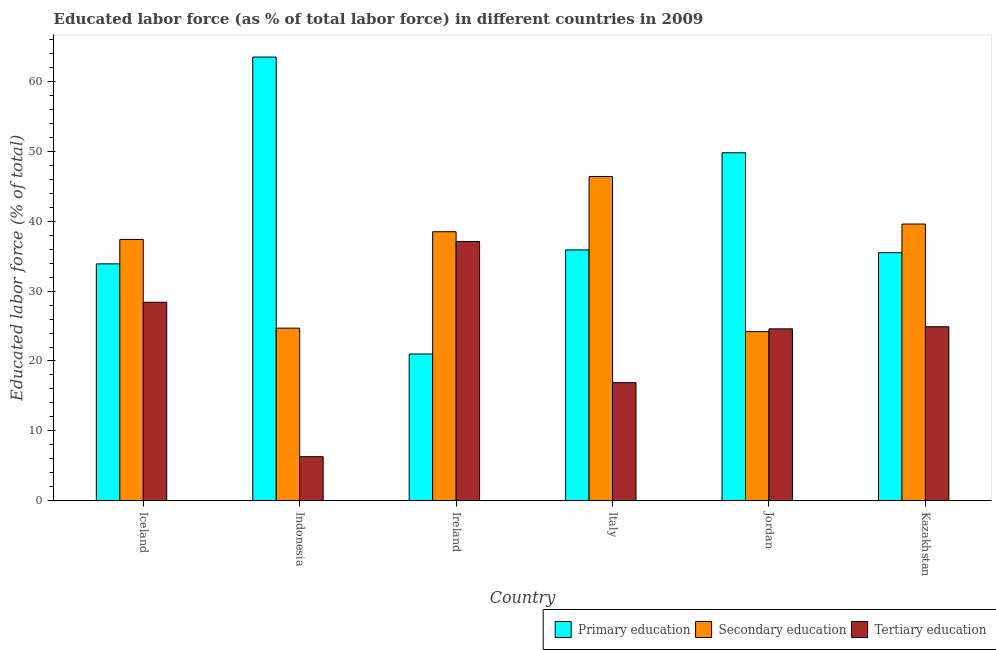How many different coloured bars are there?
Your answer should be very brief. 3. Are the number of bars per tick equal to the number of legend labels?
Provide a short and direct response. Yes. Are the number of bars on each tick of the X-axis equal?
Offer a terse response. Yes. How many bars are there on the 2nd tick from the right?
Your answer should be very brief. 3. What is the label of the 1st group of bars from the left?
Offer a very short reply. Iceland. What is the percentage of labor force who received primary education in Iceland?
Give a very brief answer. 33.9. Across all countries, what is the maximum percentage of labor force who received primary education?
Your answer should be very brief. 63.5. Across all countries, what is the minimum percentage of labor force who received primary education?
Offer a terse response. 21. In which country was the percentage of labor force who received tertiary education maximum?
Provide a short and direct response. Ireland. What is the total percentage of labor force who received primary education in the graph?
Keep it short and to the point. 239.6. What is the difference between the percentage of labor force who received tertiary education in Indonesia and that in Ireland?
Provide a succinct answer. -30.8. What is the difference between the percentage of labor force who received secondary education in Indonesia and the percentage of labor force who received tertiary education in Iceland?
Ensure brevity in your answer.  -3.7. What is the average percentage of labor force who received secondary education per country?
Give a very brief answer. 35.13. What is the difference between the percentage of labor force who received secondary education and percentage of labor force who received primary education in Italy?
Your answer should be very brief. 10.5. In how many countries, is the percentage of labor force who received primary education greater than 38 %?
Provide a succinct answer. 2. What is the ratio of the percentage of labor force who received secondary education in Iceland to that in Italy?
Your response must be concise. 0.81. What is the difference between the highest and the second highest percentage of labor force who received primary education?
Make the answer very short. 13.7. What is the difference between the highest and the lowest percentage of labor force who received primary education?
Your response must be concise. 42.5. In how many countries, is the percentage of labor force who received tertiary education greater than the average percentage of labor force who received tertiary education taken over all countries?
Provide a short and direct response. 4. Is the sum of the percentage of labor force who received primary education in Indonesia and Italy greater than the maximum percentage of labor force who received secondary education across all countries?
Ensure brevity in your answer.  Yes. What does the 3rd bar from the left in Jordan represents?
Provide a short and direct response. Tertiary education. What does the 2nd bar from the right in Jordan represents?
Ensure brevity in your answer.  Secondary education. How many bars are there?
Your answer should be very brief. 18. How many countries are there in the graph?
Keep it short and to the point. 6. What is the difference between two consecutive major ticks on the Y-axis?
Provide a succinct answer. 10. Does the graph contain any zero values?
Keep it short and to the point. No. How are the legend labels stacked?
Give a very brief answer. Horizontal. What is the title of the graph?
Give a very brief answer. Educated labor force (as % of total labor force) in different countries in 2009. What is the label or title of the X-axis?
Your answer should be very brief. Country. What is the label or title of the Y-axis?
Give a very brief answer. Educated labor force (% of total). What is the Educated labor force (% of total) in Primary education in Iceland?
Your response must be concise. 33.9. What is the Educated labor force (% of total) in Secondary education in Iceland?
Provide a succinct answer. 37.4. What is the Educated labor force (% of total) in Tertiary education in Iceland?
Keep it short and to the point. 28.4. What is the Educated labor force (% of total) of Primary education in Indonesia?
Offer a terse response. 63.5. What is the Educated labor force (% of total) in Secondary education in Indonesia?
Your response must be concise. 24.7. What is the Educated labor force (% of total) of Tertiary education in Indonesia?
Your response must be concise. 6.3. What is the Educated labor force (% of total) of Primary education in Ireland?
Offer a very short reply. 21. What is the Educated labor force (% of total) of Secondary education in Ireland?
Your response must be concise. 38.5. What is the Educated labor force (% of total) of Tertiary education in Ireland?
Keep it short and to the point. 37.1. What is the Educated labor force (% of total) of Primary education in Italy?
Your answer should be very brief. 35.9. What is the Educated labor force (% of total) of Secondary education in Italy?
Offer a very short reply. 46.4. What is the Educated labor force (% of total) in Tertiary education in Italy?
Keep it short and to the point. 16.9. What is the Educated labor force (% of total) of Primary education in Jordan?
Ensure brevity in your answer.  49.8. What is the Educated labor force (% of total) of Secondary education in Jordan?
Ensure brevity in your answer.  24.2. What is the Educated labor force (% of total) of Tertiary education in Jordan?
Give a very brief answer. 24.6. What is the Educated labor force (% of total) of Primary education in Kazakhstan?
Your answer should be compact. 35.5. What is the Educated labor force (% of total) in Secondary education in Kazakhstan?
Your response must be concise. 39.6. What is the Educated labor force (% of total) of Tertiary education in Kazakhstan?
Offer a very short reply. 24.9. Across all countries, what is the maximum Educated labor force (% of total) in Primary education?
Provide a succinct answer. 63.5. Across all countries, what is the maximum Educated labor force (% of total) in Secondary education?
Your answer should be compact. 46.4. Across all countries, what is the maximum Educated labor force (% of total) of Tertiary education?
Make the answer very short. 37.1. Across all countries, what is the minimum Educated labor force (% of total) in Primary education?
Your answer should be very brief. 21. Across all countries, what is the minimum Educated labor force (% of total) in Secondary education?
Provide a succinct answer. 24.2. Across all countries, what is the minimum Educated labor force (% of total) of Tertiary education?
Ensure brevity in your answer.  6.3. What is the total Educated labor force (% of total) in Primary education in the graph?
Your answer should be very brief. 239.6. What is the total Educated labor force (% of total) in Secondary education in the graph?
Your answer should be very brief. 210.8. What is the total Educated labor force (% of total) of Tertiary education in the graph?
Give a very brief answer. 138.2. What is the difference between the Educated labor force (% of total) of Primary education in Iceland and that in Indonesia?
Your answer should be very brief. -29.6. What is the difference between the Educated labor force (% of total) in Secondary education in Iceland and that in Indonesia?
Provide a succinct answer. 12.7. What is the difference between the Educated labor force (% of total) of Tertiary education in Iceland and that in Indonesia?
Your answer should be compact. 22.1. What is the difference between the Educated labor force (% of total) of Tertiary education in Iceland and that in Ireland?
Offer a very short reply. -8.7. What is the difference between the Educated labor force (% of total) of Secondary education in Iceland and that in Italy?
Ensure brevity in your answer.  -9. What is the difference between the Educated labor force (% of total) of Primary education in Iceland and that in Jordan?
Ensure brevity in your answer.  -15.9. What is the difference between the Educated labor force (% of total) of Tertiary education in Iceland and that in Jordan?
Your response must be concise. 3.8. What is the difference between the Educated labor force (% of total) of Secondary education in Iceland and that in Kazakhstan?
Provide a short and direct response. -2.2. What is the difference between the Educated labor force (% of total) of Primary education in Indonesia and that in Ireland?
Offer a terse response. 42.5. What is the difference between the Educated labor force (% of total) of Tertiary education in Indonesia and that in Ireland?
Your answer should be very brief. -30.8. What is the difference between the Educated labor force (% of total) in Primary education in Indonesia and that in Italy?
Make the answer very short. 27.6. What is the difference between the Educated labor force (% of total) in Secondary education in Indonesia and that in Italy?
Give a very brief answer. -21.7. What is the difference between the Educated labor force (% of total) of Tertiary education in Indonesia and that in Italy?
Your response must be concise. -10.6. What is the difference between the Educated labor force (% of total) in Primary education in Indonesia and that in Jordan?
Your answer should be compact. 13.7. What is the difference between the Educated labor force (% of total) in Tertiary education in Indonesia and that in Jordan?
Make the answer very short. -18.3. What is the difference between the Educated labor force (% of total) of Primary education in Indonesia and that in Kazakhstan?
Provide a short and direct response. 28. What is the difference between the Educated labor force (% of total) in Secondary education in Indonesia and that in Kazakhstan?
Provide a short and direct response. -14.9. What is the difference between the Educated labor force (% of total) of Tertiary education in Indonesia and that in Kazakhstan?
Keep it short and to the point. -18.6. What is the difference between the Educated labor force (% of total) in Primary education in Ireland and that in Italy?
Ensure brevity in your answer.  -14.9. What is the difference between the Educated labor force (% of total) in Secondary education in Ireland and that in Italy?
Provide a short and direct response. -7.9. What is the difference between the Educated labor force (% of total) in Tertiary education in Ireland and that in Italy?
Your answer should be very brief. 20.2. What is the difference between the Educated labor force (% of total) of Primary education in Ireland and that in Jordan?
Keep it short and to the point. -28.8. What is the difference between the Educated labor force (% of total) in Secondary education in Ireland and that in Kazakhstan?
Give a very brief answer. -1.1. What is the difference between the Educated labor force (% of total) of Tertiary education in Ireland and that in Kazakhstan?
Your answer should be compact. 12.2. What is the difference between the Educated labor force (% of total) in Primary education in Italy and that in Jordan?
Offer a terse response. -13.9. What is the difference between the Educated labor force (% of total) of Tertiary education in Italy and that in Jordan?
Make the answer very short. -7.7. What is the difference between the Educated labor force (% of total) of Primary education in Italy and that in Kazakhstan?
Provide a short and direct response. 0.4. What is the difference between the Educated labor force (% of total) of Tertiary education in Italy and that in Kazakhstan?
Your answer should be compact. -8. What is the difference between the Educated labor force (% of total) in Primary education in Jordan and that in Kazakhstan?
Make the answer very short. 14.3. What is the difference between the Educated labor force (% of total) in Secondary education in Jordan and that in Kazakhstan?
Offer a very short reply. -15.4. What is the difference between the Educated labor force (% of total) in Tertiary education in Jordan and that in Kazakhstan?
Offer a very short reply. -0.3. What is the difference between the Educated labor force (% of total) in Primary education in Iceland and the Educated labor force (% of total) in Tertiary education in Indonesia?
Make the answer very short. 27.6. What is the difference between the Educated labor force (% of total) of Secondary education in Iceland and the Educated labor force (% of total) of Tertiary education in Indonesia?
Keep it short and to the point. 31.1. What is the difference between the Educated labor force (% of total) of Secondary education in Iceland and the Educated labor force (% of total) of Tertiary education in Italy?
Offer a very short reply. 20.5. What is the difference between the Educated labor force (% of total) in Primary education in Iceland and the Educated labor force (% of total) in Secondary education in Jordan?
Your answer should be very brief. 9.7. What is the difference between the Educated labor force (% of total) of Secondary education in Iceland and the Educated labor force (% of total) of Tertiary education in Jordan?
Your answer should be compact. 12.8. What is the difference between the Educated labor force (% of total) of Secondary education in Iceland and the Educated labor force (% of total) of Tertiary education in Kazakhstan?
Your answer should be very brief. 12.5. What is the difference between the Educated labor force (% of total) of Primary education in Indonesia and the Educated labor force (% of total) of Secondary education in Ireland?
Offer a very short reply. 25. What is the difference between the Educated labor force (% of total) in Primary education in Indonesia and the Educated labor force (% of total) in Tertiary education in Ireland?
Provide a short and direct response. 26.4. What is the difference between the Educated labor force (% of total) in Secondary education in Indonesia and the Educated labor force (% of total) in Tertiary education in Ireland?
Provide a short and direct response. -12.4. What is the difference between the Educated labor force (% of total) in Primary education in Indonesia and the Educated labor force (% of total) in Tertiary education in Italy?
Your answer should be compact. 46.6. What is the difference between the Educated labor force (% of total) in Secondary education in Indonesia and the Educated labor force (% of total) in Tertiary education in Italy?
Your response must be concise. 7.8. What is the difference between the Educated labor force (% of total) in Primary education in Indonesia and the Educated labor force (% of total) in Secondary education in Jordan?
Ensure brevity in your answer.  39.3. What is the difference between the Educated labor force (% of total) of Primary education in Indonesia and the Educated labor force (% of total) of Tertiary education in Jordan?
Your answer should be very brief. 38.9. What is the difference between the Educated labor force (% of total) in Secondary education in Indonesia and the Educated labor force (% of total) in Tertiary education in Jordan?
Provide a succinct answer. 0.1. What is the difference between the Educated labor force (% of total) of Primary education in Indonesia and the Educated labor force (% of total) of Secondary education in Kazakhstan?
Ensure brevity in your answer.  23.9. What is the difference between the Educated labor force (% of total) in Primary education in Indonesia and the Educated labor force (% of total) in Tertiary education in Kazakhstan?
Your response must be concise. 38.6. What is the difference between the Educated labor force (% of total) in Secondary education in Indonesia and the Educated labor force (% of total) in Tertiary education in Kazakhstan?
Make the answer very short. -0.2. What is the difference between the Educated labor force (% of total) of Primary education in Ireland and the Educated labor force (% of total) of Secondary education in Italy?
Give a very brief answer. -25.4. What is the difference between the Educated labor force (% of total) in Primary education in Ireland and the Educated labor force (% of total) in Tertiary education in Italy?
Make the answer very short. 4.1. What is the difference between the Educated labor force (% of total) in Secondary education in Ireland and the Educated labor force (% of total) in Tertiary education in Italy?
Make the answer very short. 21.6. What is the difference between the Educated labor force (% of total) in Primary education in Ireland and the Educated labor force (% of total) in Secondary education in Kazakhstan?
Your answer should be very brief. -18.6. What is the difference between the Educated labor force (% of total) in Primary education in Italy and the Educated labor force (% of total) in Tertiary education in Jordan?
Provide a succinct answer. 11.3. What is the difference between the Educated labor force (% of total) of Secondary education in Italy and the Educated labor force (% of total) of Tertiary education in Jordan?
Offer a very short reply. 21.8. What is the difference between the Educated labor force (% of total) of Primary education in Italy and the Educated labor force (% of total) of Secondary education in Kazakhstan?
Your answer should be compact. -3.7. What is the difference between the Educated labor force (% of total) in Primary education in Jordan and the Educated labor force (% of total) in Tertiary education in Kazakhstan?
Give a very brief answer. 24.9. What is the difference between the Educated labor force (% of total) of Secondary education in Jordan and the Educated labor force (% of total) of Tertiary education in Kazakhstan?
Your response must be concise. -0.7. What is the average Educated labor force (% of total) in Primary education per country?
Provide a short and direct response. 39.93. What is the average Educated labor force (% of total) in Secondary education per country?
Give a very brief answer. 35.13. What is the average Educated labor force (% of total) in Tertiary education per country?
Your answer should be very brief. 23.03. What is the difference between the Educated labor force (% of total) of Primary education and Educated labor force (% of total) of Secondary education in Iceland?
Make the answer very short. -3.5. What is the difference between the Educated labor force (% of total) in Primary education and Educated labor force (% of total) in Tertiary education in Iceland?
Your answer should be compact. 5.5. What is the difference between the Educated labor force (% of total) in Secondary education and Educated labor force (% of total) in Tertiary education in Iceland?
Make the answer very short. 9. What is the difference between the Educated labor force (% of total) of Primary education and Educated labor force (% of total) of Secondary education in Indonesia?
Give a very brief answer. 38.8. What is the difference between the Educated labor force (% of total) of Primary education and Educated labor force (% of total) of Tertiary education in Indonesia?
Your answer should be compact. 57.2. What is the difference between the Educated labor force (% of total) of Primary education and Educated labor force (% of total) of Secondary education in Ireland?
Your answer should be very brief. -17.5. What is the difference between the Educated labor force (% of total) of Primary education and Educated labor force (% of total) of Tertiary education in Ireland?
Make the answer very short. -16.1. What is the difference between the Educated labor force (% of total) of Secondary education and Educated labor force (% of total) of Tertiary education in Ireland?
Offer a terse response. 1.4. What is the difference between the Educated labor force (% of total) in Secondary education and Educated labor force (% of total) in Tertiary education in Italy?
Offer a terse response. 29.5. What is the difference between the Educated labor force (% of total) of Primary education and Educated labor force (% of total) of Secondary education in Jordan?
Offer a very short reply. 25.6. What is the difference between the Educated labor force (% of total) of Primary education and Educated labor force (% of total) of Tertiary education in Jordan?
Provide a short and direct response. 25.2. What is the difference between the Educated labor force (% of total) of Primary education and Educated labor force (% of total) of Tertiary education in Kazakhstan?
Provide a succinct answer. 10.6. What is the ratio of the Educated labor force (% of total) in Primary education in Iceland to that in Indonesia?
Your answer should be very brief. 0.53. What is the ratio of the Educated labor force (% of total) in Secondary education in Iceland to that in Indonesia?
Offer a very short reply. 1.51. What is the ratio of the Educated labor force (% of total) of Tertiary education in Iceland to that in Indonesia?
Provide a succinct answer. 4.51. What is the ratio of the Educated labor force (% of total) of Primary education in Iceland to that in Ireland?
Ensure brevity in your answer.  1.61. What is the ratio of the Educated labor force (% of total) in Secondary education in Iceland to that in Ireland?
Offer a very short reply. 0.97. What is the ratio of the Educated labor force (% of total) of Tertiary education in Iceland to that in Ireland?
Your response must be concise. 0.77. What is the ratio of the Educated labor force (% of total) of Primary education in Iceland to that in Italy?
Provide a short and direct response. 0.94. What is the ratio of the Educated labor force (% of total) of Secondary education in Iceland to that in Italy?
Offer a terse response. 0.81. What is the ratio of the Educated labor force (% of total) of Tertiary education in Iceland to that in Italy?
Keep it short and to the point. 1.68. What is the ratio of the Educated labor force (% of total) in Primary education in Iceland to that in Jordan?
Your answer should be very brief. 0.68. What is the ratio of the Educated labor force (% of total) of Secondary education in Iceland to that in Jordan?
Provide a short and direct response. 1.55. What is the ratio of the Educated labor force (% of total) of Tertiary education in Iceland to that in Jordan?
Make the answer very short. 1.15. What is the ratio of the Educated labor force (% of total) in Primary education in Iceland to that in Kazakhstan?
Your answer should be very brief. 0.95. What is the ratio of the Educated labor force (% of total) in Secondary education in Iceland to that in Kazakhstan?
Provide a succinct answer. 0.94. What is the ratio of the Educated labor force (% of total) in Tertiary education in Iceland to that in Kazakhstan?
Your response must be concise. 1.14. What is the ratio of the Educated labor force (% of total) in Primary education in Indonesia to that in Ireland?
Provide a succinct answer. 3.02. What is the ratio of the Educated labor force (% of total) in Secondary education in Indonesia to that in Ireland?
Keep it short and to the point. 0.64. What is the ratio of the Educated labor force (% of total) of Tertiary education in Indonesia to that in Ireland?
Your answer should be very brief. 0.17. What is the ratio of the Educated labor force (% of total) in Primary education in Indonesia to that in Italy?
Offer a very short reply. 1.77. What is the ratio of the Educated labor force (% of total) of Secondary education in Indonesia to that in Italy?
Your answer should be very brief. 0.53. What is the ratio of the Educated labor force (% of total) of Tertiary education in Indonesia to that in Italy?
Offer a terse response. 0.37. What is the ratio of the Educated labor force (% of total) in Primary education in Indonesia to that in Jordan?
Offer a terse response. 1.28. What is the ratio of the Educated labor force (% of total) in Secondary education in Indonesia to that in Jordan?
Provide a succinct answer. 1.02. What is the ratio of the Educated labor force (% of total) in Tertiary education in Indonesia to that in Jordan?
Your answer should be very brief. 0.26. What is the ratio of the Educated labor force (% of total) of Primary education in Indonesia to that in Kazakhstan?
Your answer should be compact. 1.79. What is the ratio of the Educated labor force (% of total) in Secondary education in Indonesia to that in Kazakhstan?
Your answer should be very brief. 0.62. What is the ratio of the Educated labor force (% of total) in Tertiary education in Indonesia to that in Kazakhstan?
Your answer should be compact. 0.25. What is the ratio of the Educated labor force (% of total) of Primary education in Ireland to that in Italy?
Ensure brevity in your answer.  0.58. What is the ratio of the Educated labor force (% of total) of Secondary education in Ireland to that in Italy?
Make the answer very short. 0.83. What is the ratio of the Educated labor force (% of total) of Tertiary education in Ireland to that in Italy?
Offer a very short reply. 2.2. What is the ratio of the Educated labor force (% of total) in Primary education in Ireland to that in Jordan?
Your response must be concise. 0.42. What is the ratio of the Educated labor force (% of total) in Secondary education in Ireland to that in Jordan?
Make the answer very short. 1.59. What is the ratio of the Educated labor force (% of total) of Tertiary education in Ireland to that in Jordan?
Provide a short and direct response. 1.51. What is the ratio of the Educated labor force (% of total) in Primary education in Ireland to that in Kazakhstan?
Your response must be concise. 0.59. What is the ratio of the Educated labor force (% of total) in Secondary education in Ireland to that in Kazakhstan?
Keep it short and to the point. 0.97. What is the ratio of the Educated labor force (% of total) of Tertiary education in Ireland to that in Kazakhstan?
Your answer should be very brief. 1.49. What is the ratio of the Educated labor force (% of total) of Primary education in Italy to that in Jordan?
Keep it short and to the point. 0.72. What is the ratio of the Educated labor force (% of total) in Secondary education in Italy to that in Jordan?
Your answer should be compact. 1.92. What is the ratio of the Educated labor force (% of total) of Tertiary education in Italy to that in Jordan?
Offer a very short reply. 0.69. What is the ratio of the Educated labor force (% of total) of Primary education in Italy to that in Kazakhstan?
Your response must be concise. 1.01. What is the ratio of the Educated labor force (% of total) of Secondary education in Italy to that in Kazakhstan?
Your response must be concise. 1.17. What is the ratio of the Educated labor force (% of total) in Tertiary education in Italy to that in Kazakhstan?
Offer a very short reply. 0.68. What is the ratio of the Educated labor force (% of total) of Primary education in Jordan to that in Kazakhstan?
Provide a succinct answer. 1.4. What is the ratio of the Educated labor force (% of total) in Secondary education in Jordan to that in Kazakhstan?
Offer a very short reply. 0.61. What is the difference between the highest and the lowest Educated labor force (% of total) of Primary education?
Give a very brief answer. 42.5. What is the difference between the highest and the lowest Educated labor force (% of total) in Secondary education?
Give a very brief answer. 22.2. What is the difference between the highest and the lowest Educated labor force (% of total) of Tertiary education?
Keep it short and to the point. 30.8. 